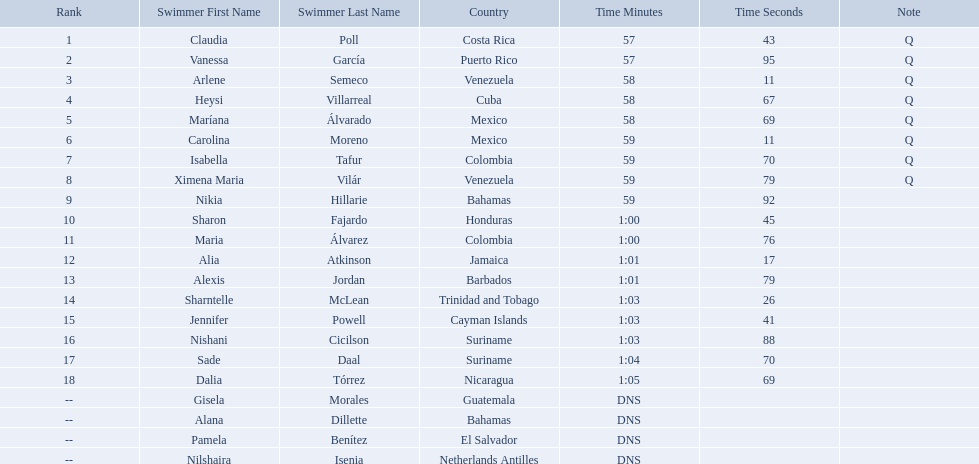Where were the top eight finishers from? Costa Rica, Puerto Rico, Venezuela, Cuba, Mexico, Mexico, Colombia, Venezuela. Which of the top eight were from cuba? Heysi Villarreal. Who were the swimmers at the 2006 central american and caribbean games - women's 100 metre freestyle? Claudia Poll, Vanessa García, Arlene Semeco, Heysi Villarreal, Maríana Álvarado, Carolina Moreno, Isabella Tafur, Ximena Maria Vilár, Nikia Hillarie, Sharon Fajardo, Maria Álvarez, Alia Atkinson, Alexis Jordan, Sharntelle McLean, Jennifer Powell, Nishani Cicilson, Sade Daal, Dalia Tórrez, Gisela Morales, Alana Dillette, Pamela Benítez, Nilshaira Isenia. Of these which were from cuba? Heysi Villarreal. 